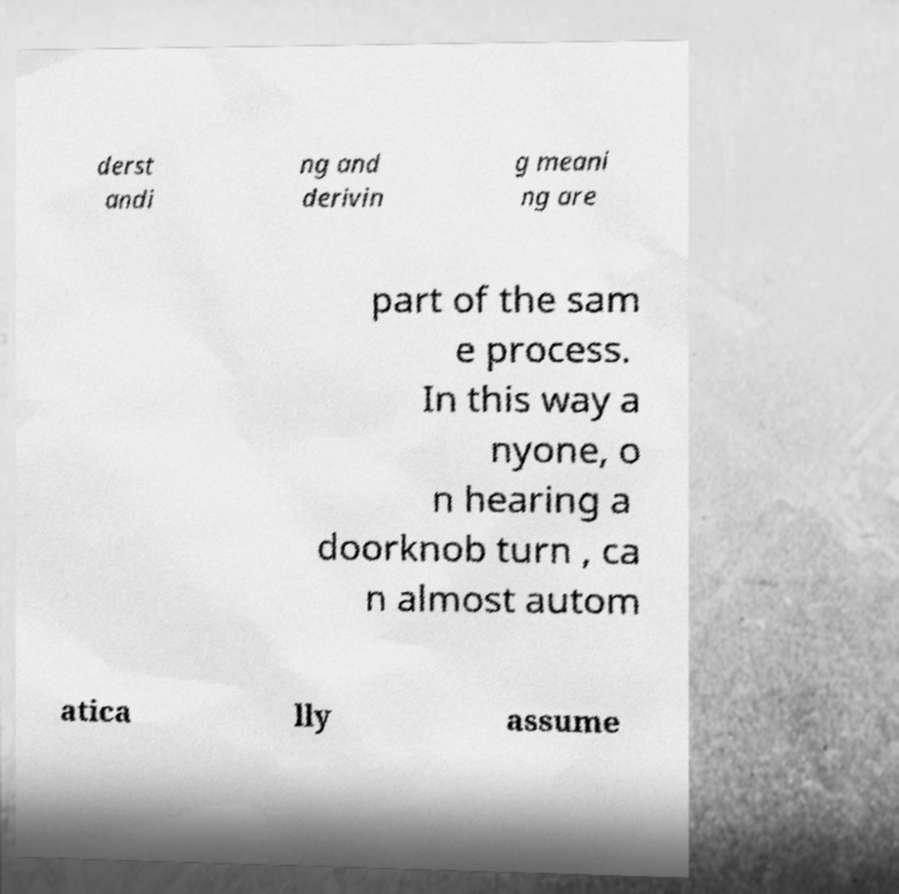Can you accurately transcribe the text from the provided image for me? derst andi ng and derivin g meani ng are part of the sam e process. In this way a nyone, o n hearing a doorknob turn , ca n almost autom atica lly assume 